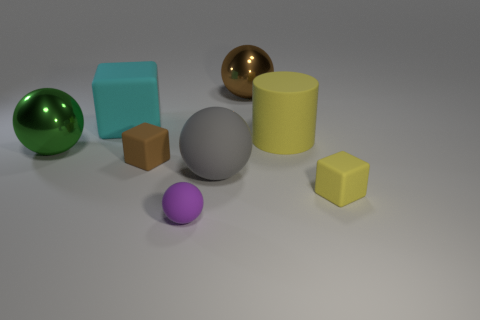Subtract 1 spheres. How many spheres are left? 3 Add 1 gray rubber balls. How many objects exist? 9 Subtract all cylinders. How many objects are left? 7 Add 6 tiny metal objects. How many tiny metal objects exist? 6 Subtract 0 green blocks. How many objects are left? 8 Subtract all large cyan cubes. Subtract all brown matte balls. How many objects are left? 7 Add 2 brown matte cubes. How many brown matte cubes are left? 3 